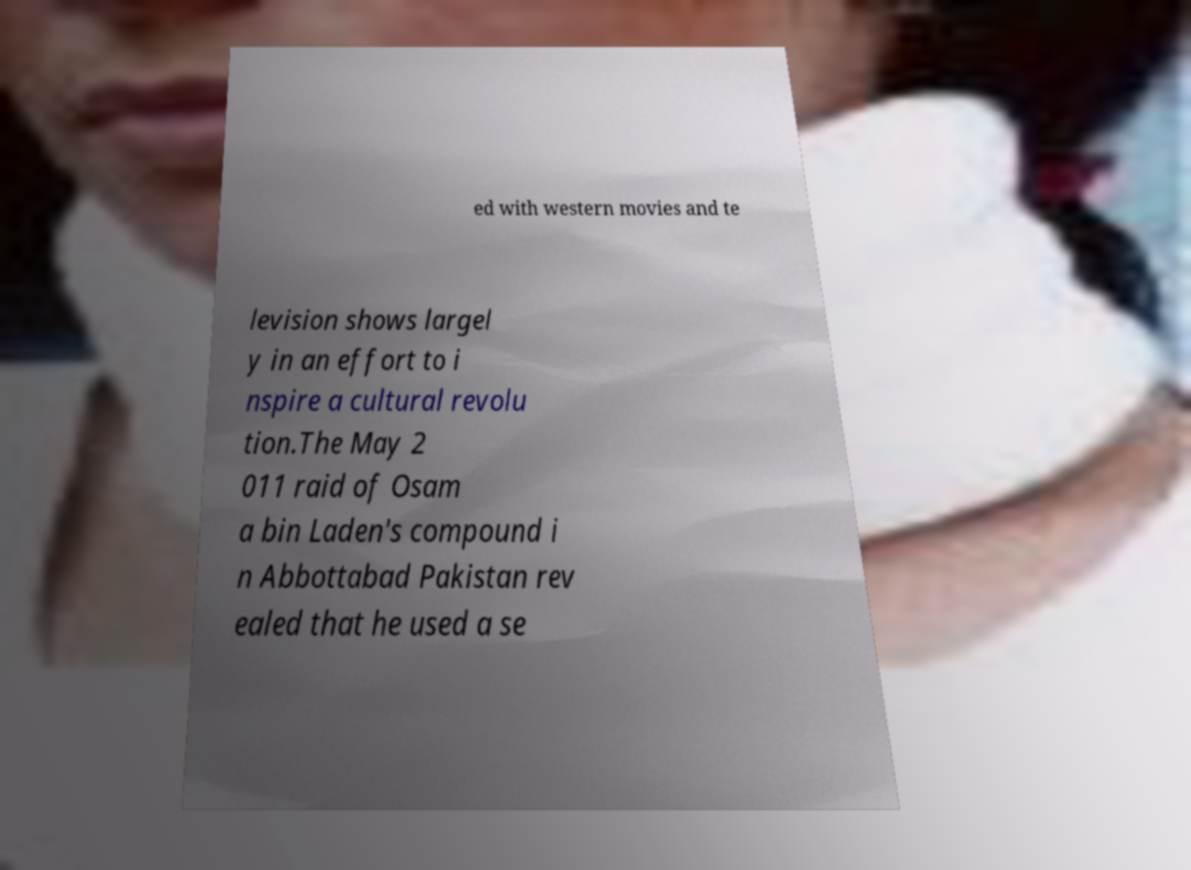Please identify and transcribe the text found in this image. ed with western movies and te levision shows largel y in an effort to i nspire a cultural revolu tion.The May 2 011 raid of Osam a bin Laden's compound i n Abbottabad Pakistan rev ealed that he used a se 